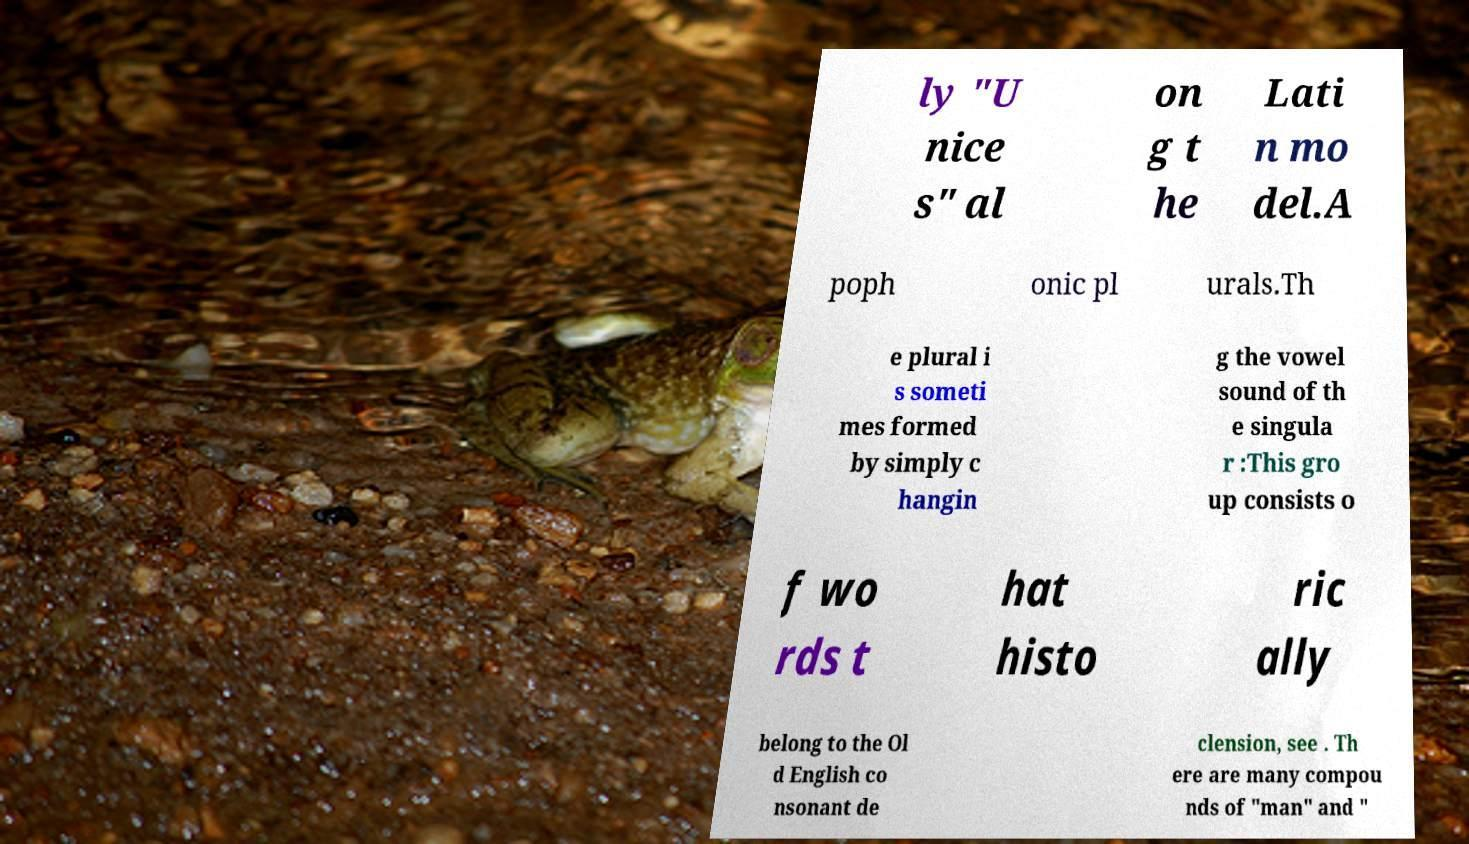There's text embedded in this image that I need extracted. Can you transcribe it verbatim? ly "U nice s" al on g t he Lati n mo del.A poph onic pl urals.Th e plural i s someti mes formed by simply c hangin g the vowel sound of th e singula r :This gro up consists o f wo rds t hat histo ric ally belong to the Ol d English co nsonant de clension, see . Th ere are many compou nds of "man" and " 